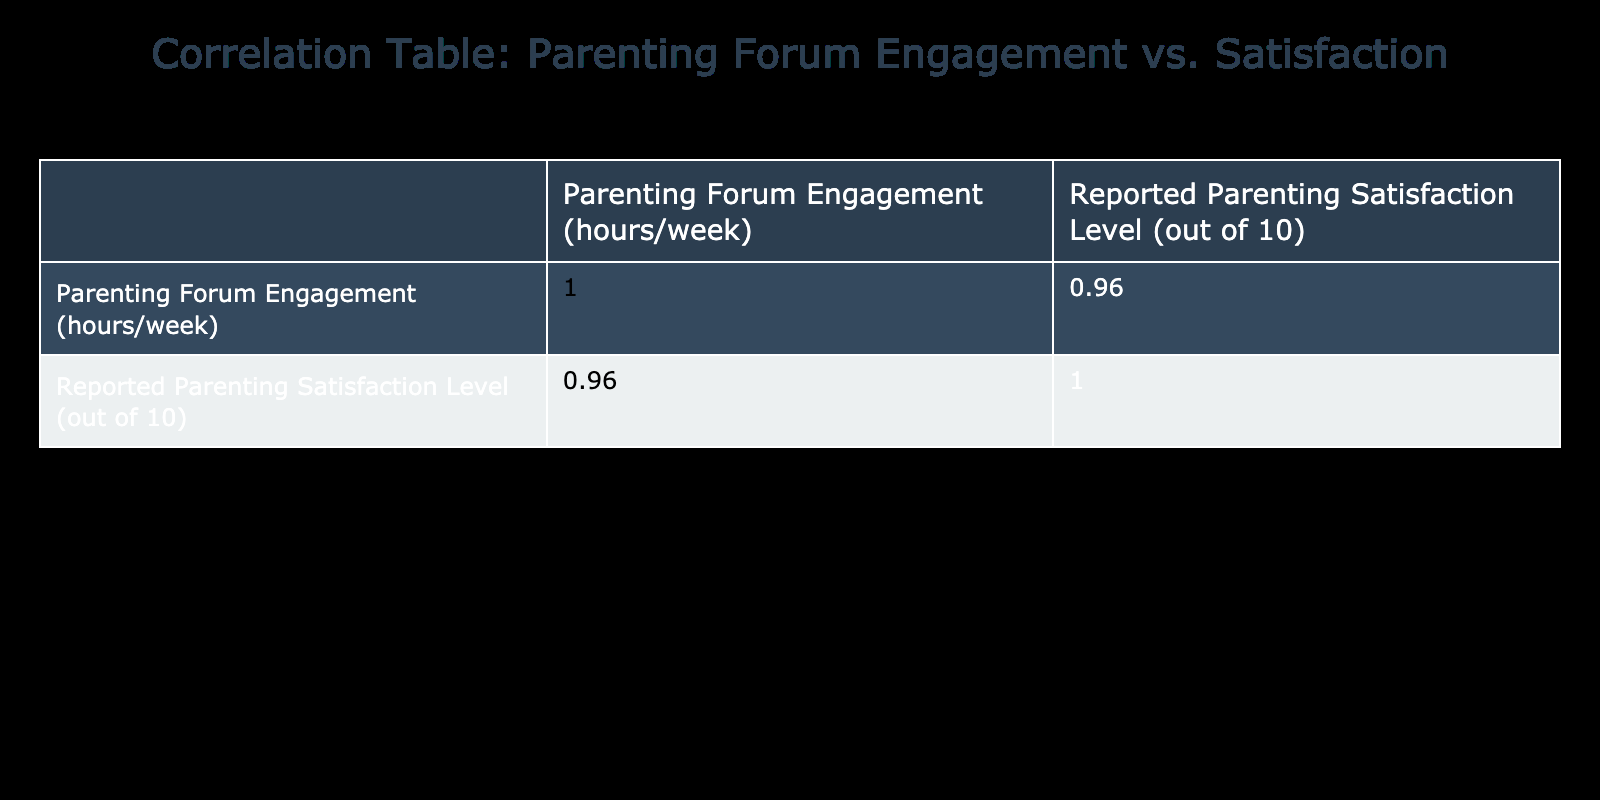What is the correlation coefficient between Parenting Forum Engagement and Reported Parenting Satisfaction Level? The correlation coefficient is directly present in the table, specifically where the two variables intersect. I look at the cell where the Parenting Forum Engagement row and the Reported Parenting Satisfaction Level column meet. The value there is 0.93.
Answer: 0.93 Is the reported parenting satisfaction level higher when forum engagement is above 5 hours a week? I check the items where forum engagement is above 5 hours per week, which are 6, 7, 8, 9, and 10. Their corresponding reported satisfaction levels are 8, 7, 8, 9, and 9. The average of these is (8 + 7 + 8 + 9 + 9) / 5 = 8.2, which is higher than the overall satisfaction mean.
Answer: Yes What is the average reported parenting satisfaction level for those who engage with the forum for 4 hours or less? I look at the engagement levels of 1, 2, 3, and 4 hours. The satisfaction levels associated with these are 4, 5, 6, and 6. Summing them gives 4 + 5 + 6 + 6 = 21. There are four entries, so the average is 21 / 4 = 5.25.
Answer: 5.25 Did any parents report a satisfaction level of 10? I scan the reported parenting satisfaction levels to see if there is a 10. The values listed are 4, 5, 6, 7, 8, 9, which do not include ten.
Answer: No Which engagement level correlates with the highest satisfaction level, and what is that level? I look for the highest number in the satisfaction levels, which is 9 appearing at engagement levels of 9 and 10. I conclude that both engagement levels of 9 and 10 correlate with the highest satisfaction level.
Answer: 9 and 10 What is the difference in parenting satisfaction levels between those engaging with the forum for 1 hour and those engaging for 10 hours? The satisfaction level for 1 hour is 4 and for 10 hours is 9. I find the difference by subtracting: 9 - 4 = 5.
Answer: 5 On average, how much satisfaction is reported by parents who engage with forums for 3 hours or more? I identify the entries with 3 or more hours which are 3, 4, 5, 6, 7, 8, 9, and 10, with their satisfaction levels being 6, 6, 7, 8, 7, 8, 9, and 9. Summing these gives 60 and dividing by 8 gives 60 / 8 = 7.5.
Answer: 7.5 Is there a consistent increase in satisfaction levels with increased forum engagement hours? I examine the correlation coefficient, which is 0.93, indicating a strong positive relationship between engagement and satisfaction. However, the other values do not consistently increase by engagement levels.
Answer: No 